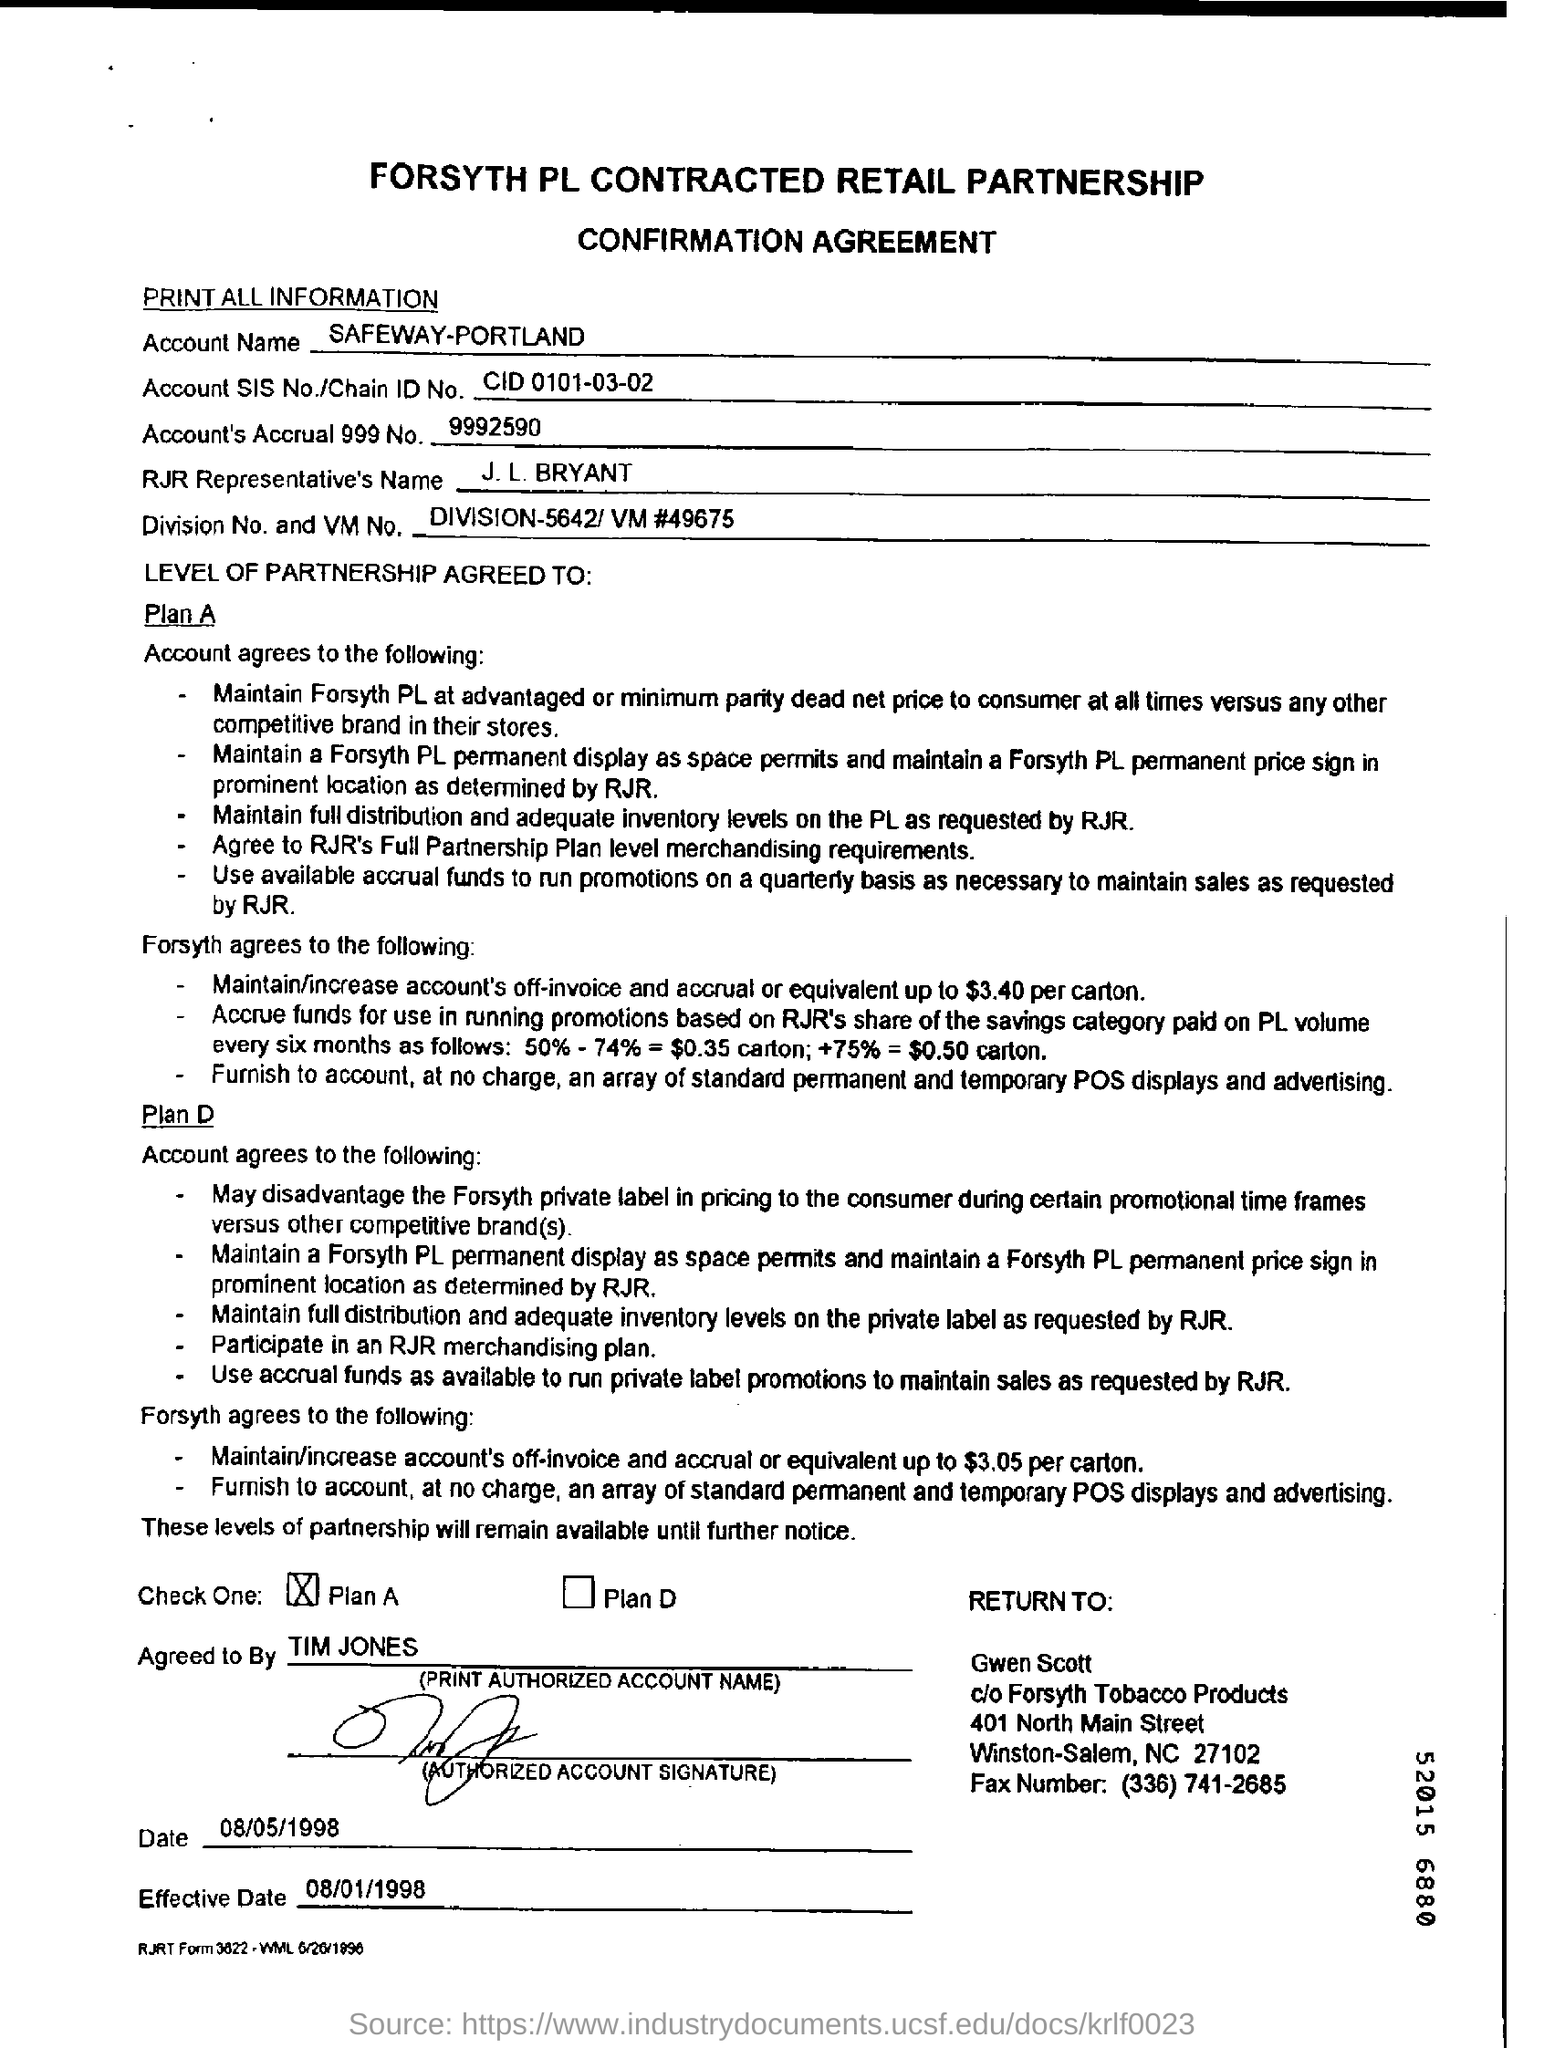List a handful of essential elements in this visual. The effective date mentioned is 08/01/1998. The RJR Representative is J.L. Bryant. 